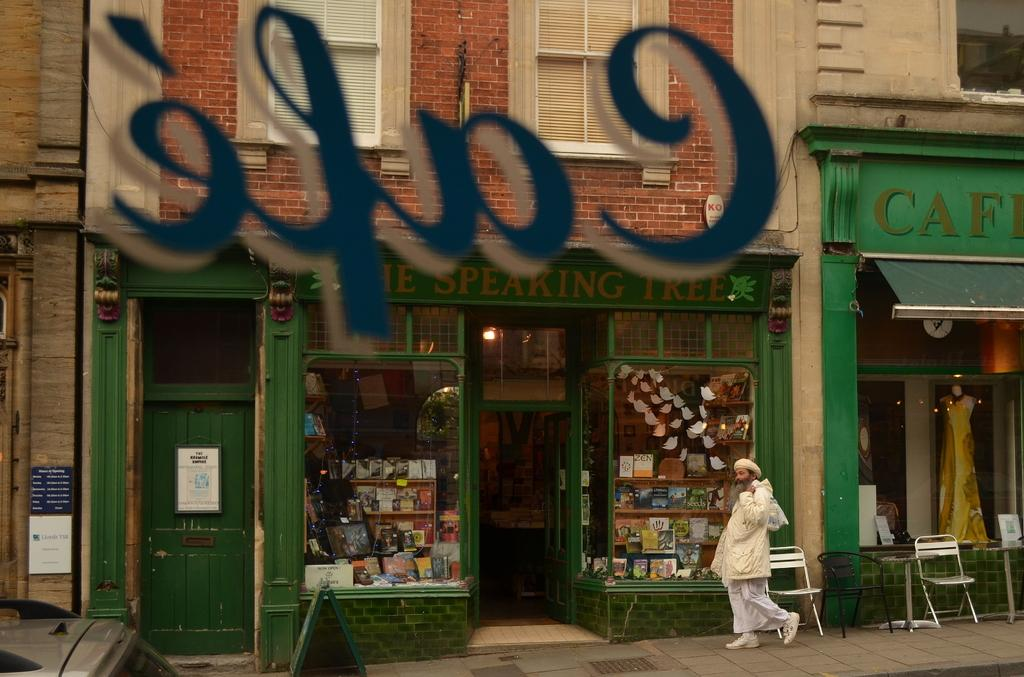<image>
Describe the image concisely. A man in white walking past the open door of The Speaking Tree 